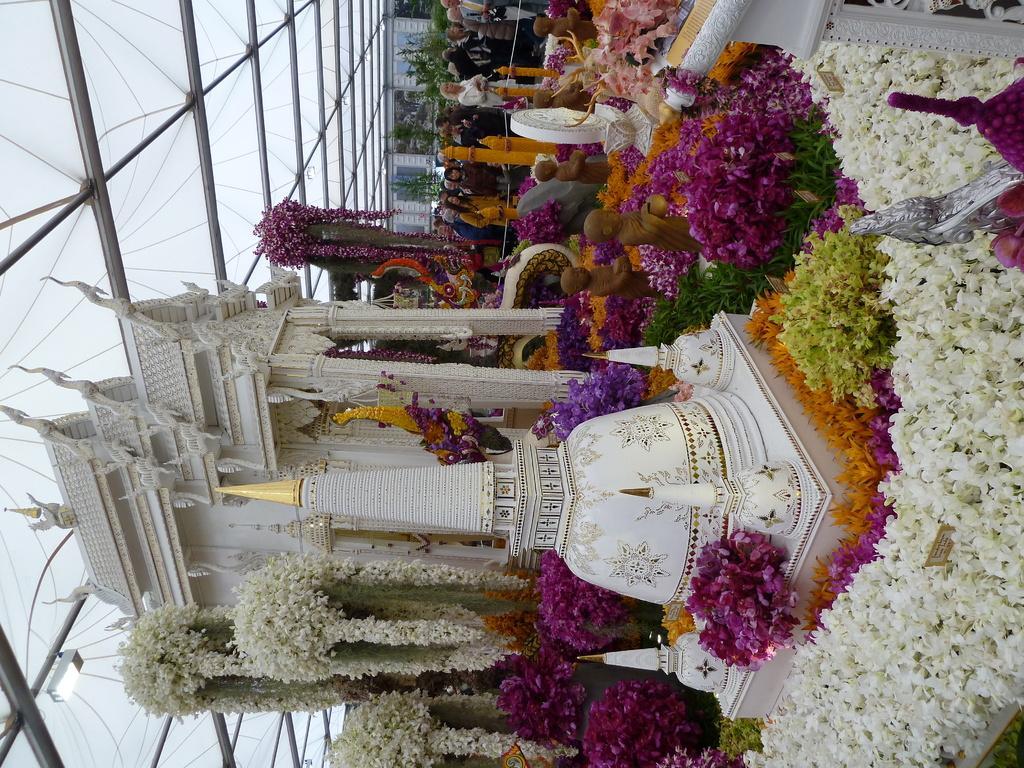Describe this image in one or two sentences. In the middle of the picture, we see a monument. Beside that, we see the plants and the flowers in white, pink and orange color. Beside that, we see the statues. At the top of the picture, we see the people are standing. In the background, we see a building in white color. On the left side, we see a light and the glass roof. 